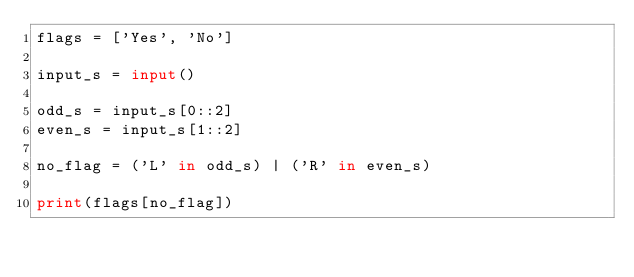Convert code to text. <code><loc_0><loc_0><loc_500><loc_500><_Python_>flags = ['Yes', 'No']

input_s = input()

odd_s = input_s[0::2]
even_s = input_s[1::2]

no_flag = ('L' in odd_s) | ('R' in even_s)

print(flags[no_flag])</code> 